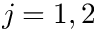<formula> <loc_0><loc_0><loc_500><loc_500>j = 1 , 2</formula> 